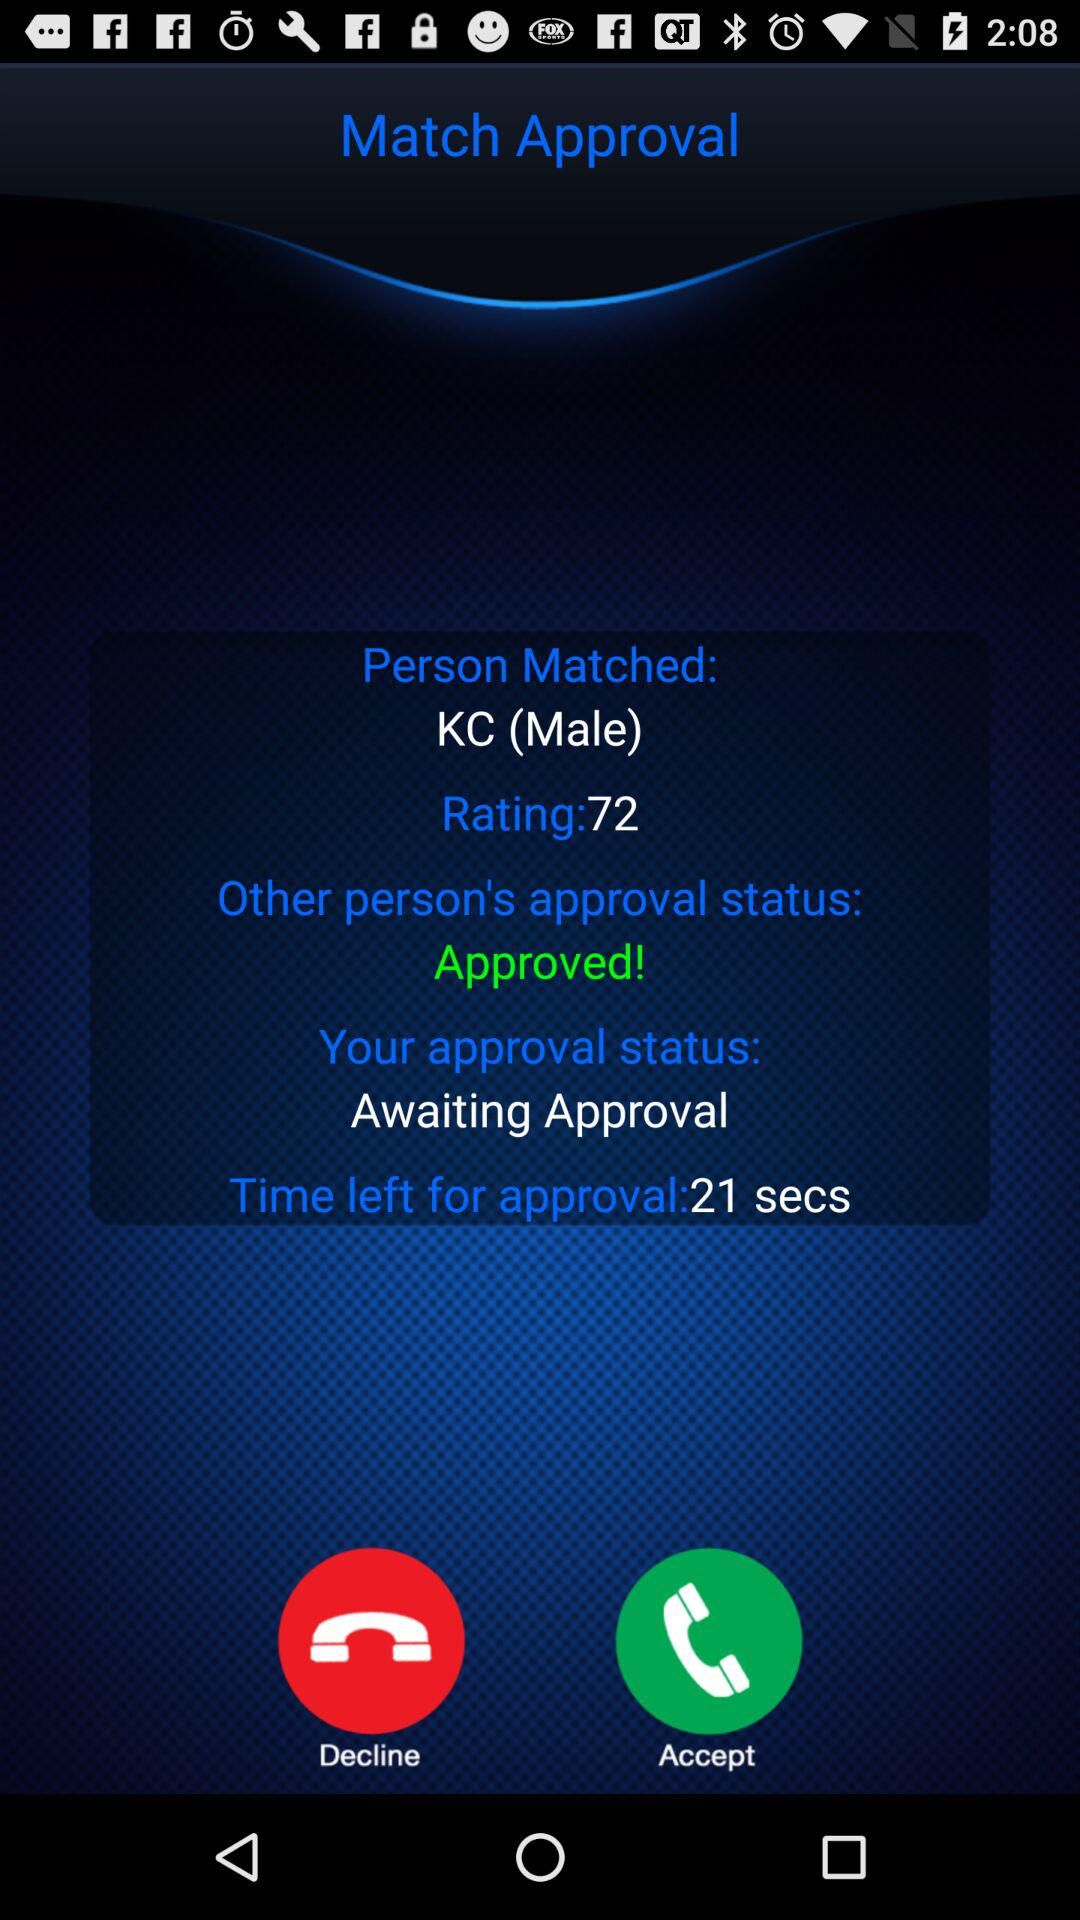What is the status of the "Other Person's approval"? The status is "Approved". 